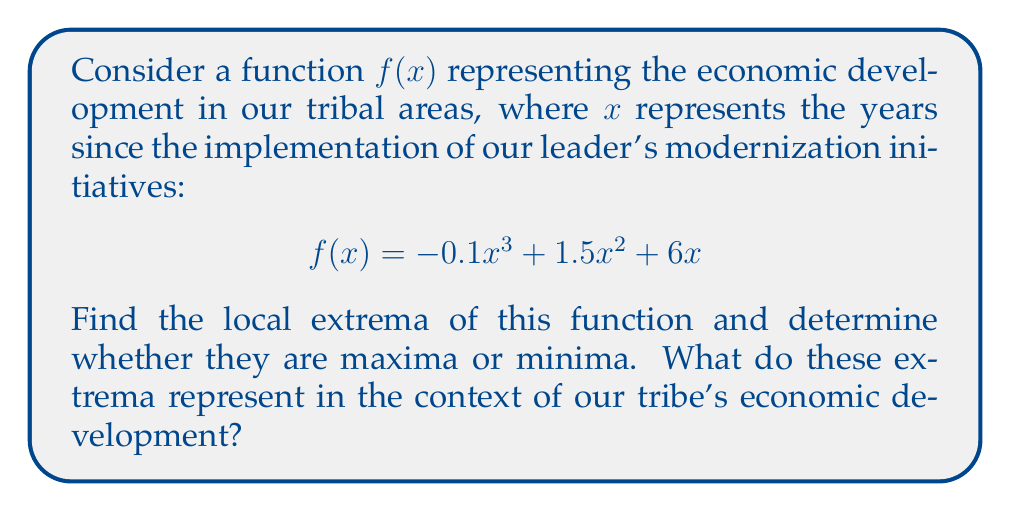Could you help me with this problem? To find the local extrema of the function $f(x) = -0.1x^3 + 1.5x^2 + 6x$, we need to follow these steps:

1) First, we find the critical points by taking the derivative of $f(x)$ and setting it equal to zero:

   $$f'(x) = -0.3x^2 + 3x + 6$$
   $$-0.3x^2 + 3x + 6 = 0$$

2) This is a quadratic equation. We can solve it using the quadratic formula:
   $$x = \frac{-b \pm \sqrt{b^2 - 4ac}}{2a}$$
   
   Where $a = -0.3$, $b = 3$, and $c = 6$

3) Plugging in these values:
   $$x = \frac{-3 \pm \sqrt{3^2 - 4(-0.3)(6)}}{2(-0.3)}$$
   $$x = \frac{-3 \pm \sqrt{9 + 7.2}}{-0.6}$$
   $$x = \frac{-3 \pm \sqrt{16.2}}{-0.6}$$
   $$x = \frac{-3 \pm 4.025}{-0.6}$$

4) This gives us two critical points:
   $$x_1 = \frac{-3 - 4.025}{-0.6} \approx 11.71$$
   $$x_2 = \frac{-3 + 4.025}{-0.6} \approx -1.71$$

5) To determine if these points are maxima or minima, we can use the second derivative test:
   $$f''(x) = -0.6x + 3$$
   
   At $x_1 \approx 11.71$: $f''(11.71) \approx -4.03 < 0$, so this is a local maximum.
   At $x_2 \approx -1.71$: $f''(-1.71) \approx 4.03 > 0$, so this is a local minimum.

6) The y-values at these points are:
   $$f(11.71) \approx 130.65$$
   $$f(-1.71) \approx -15.65$$

In the context of our tribe's economic development, the local maximum at approximately 11.71 years represents the peak of economic growth under the current initiatives. After this point, the rate of growth begins to slow down. The local minimum at approximately -1.71 years (which is before the start of the initiatives) represents a low point in our economic development, from which we have been steadily improving.
Answer: The function has a local maximum at approximately (11.71, 130.65) and a local minimum at approximately (-1.71, -15.65). These represent the peak of economic growth and the low point before the initiatives, respectively, in our tribe's economic development trajectory. 